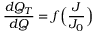Convert formula to latex. <formula><loc_0><loc_0><loc_500><loc_500>\frac { d Q _ { T } } { d Q } = f \left ( \frac { J } { J _ { 0 } } \right )</formula> 